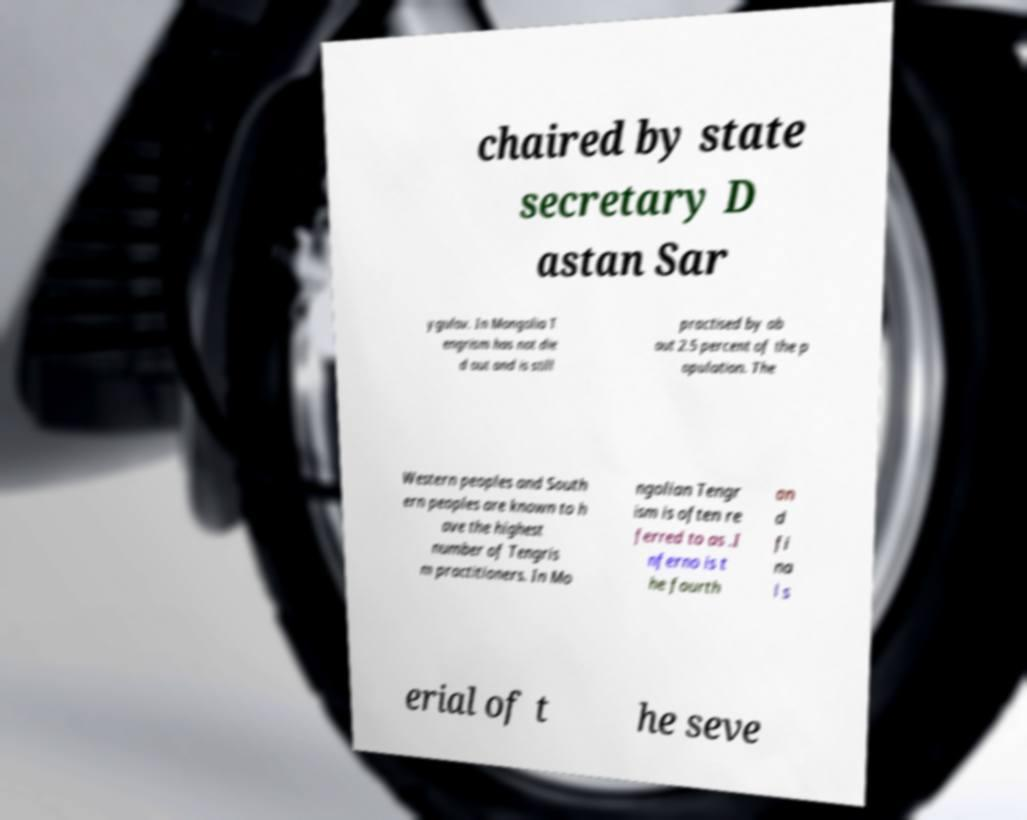There's text embedded in this image that I need extracted. Can you transcribe it verbatim? chaired by state secretary D astan Sar ygulov. In Mongolia T engrism has not die d out and is still practised by ab out 2.5 percent of the p opulation. The Western peoples and South ern peoples are known to h ave the highest number of Tengris m practitioners. In Mo ngolian Tengr ism is often re ferred to as .I nferno is t he fourth an d fi na l s erial of t he seve 